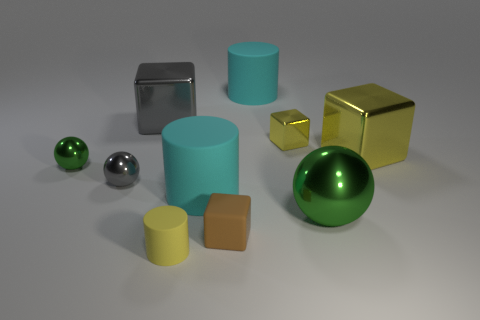Subtract all small yellow cylinders. How many cylinders are left? 2 Subtract all yellow cylinders. How many cylinders are left? 2 Subtract all cylinders. How many objects are left? 7 Subtract 2 balls. How many balls are left? 1 Subtract all blue spheres. How many gray blocks are left? 1 Subtract all cyan cylinders. Subtract all rubber cylinders. How many objects are left? 5 Add 1 brown blocks. How many brown blocks are left? 2 Add 9 small brown balls. How many small brown balls exist? 9 Subtract 0 brown balls. How many objects are left? 10 Subtract all purple blocks. Subtract all blue cylinders. How many blocks are left? 4 